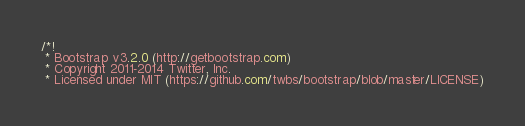<code> <loc_0><loc_0><loc_500><loc_500><_CSS_>/*!
 * Bootstrap v3.2.0 (http://getbootstrap.com)
 * Copyright 2011-2014 Twitter, Inc.
 * Licensed under MIT (https://github.com/twbs/bootstrap/blob/master/LICENSE)</code> 